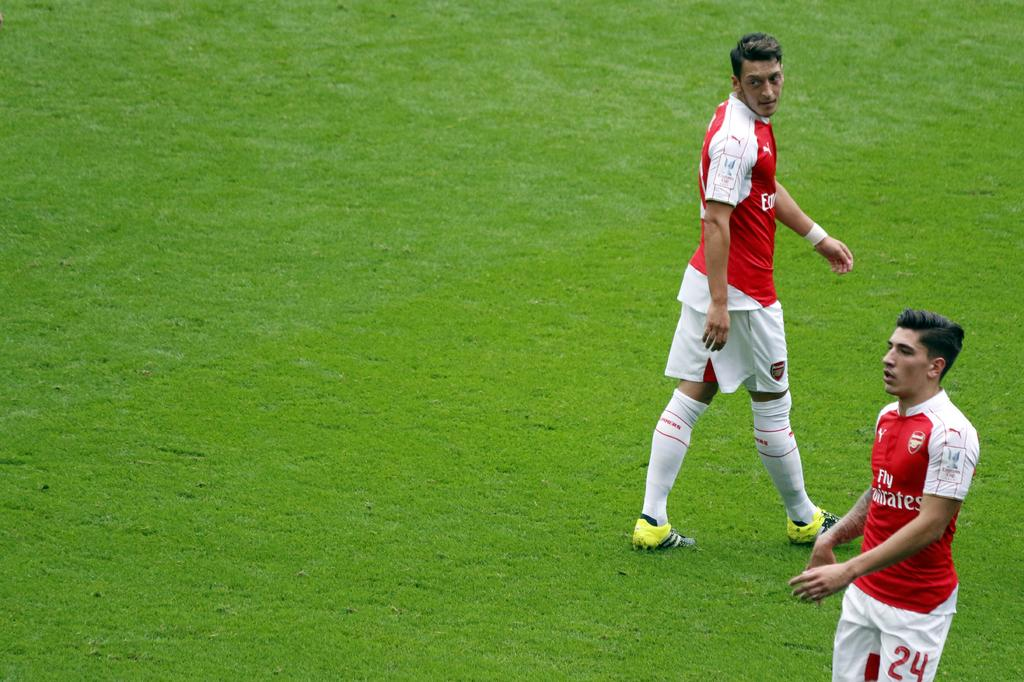How many people are in the image? There are two persons in the image. What are the persons wearing? The persons are wearing jerseys. What colors are the jerseys? One person's jersey is red, and the other's is white. What are the persons doing in the image? The persons are standing. What type of surface is visible on the ground in the image? There is grass on the ground in the image. What year is depicted on the stage in the image? There is no stage present in the image, and therefore no year can be associated with it. 